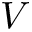<formula> <loc_0><loc_0><loc_500><loc_500>V</formula> 